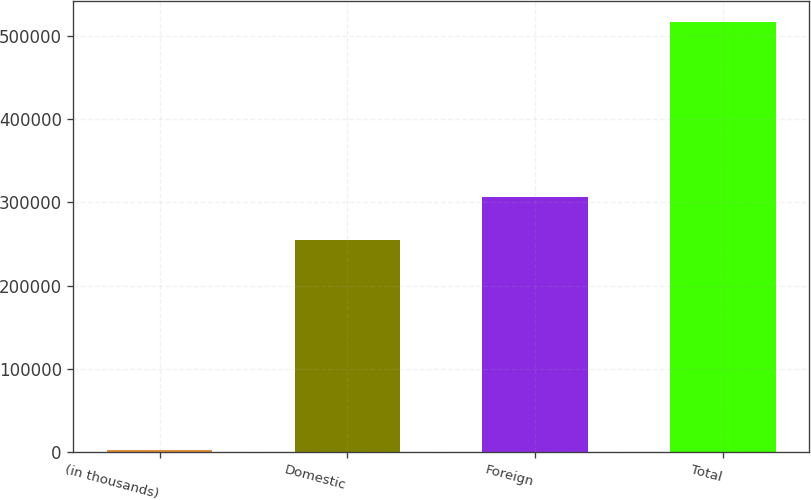Convert chart to OTSL. <chart><loc_0><loc_0><loc_500><loc_500><bar_chart><fcel>(in thousands)<fcel>Domestic<fcel>Foreign<fcel>Total<nl><fcel>2004<fcel>254582<fcel>305986<fcel>516041<nl></chart> 